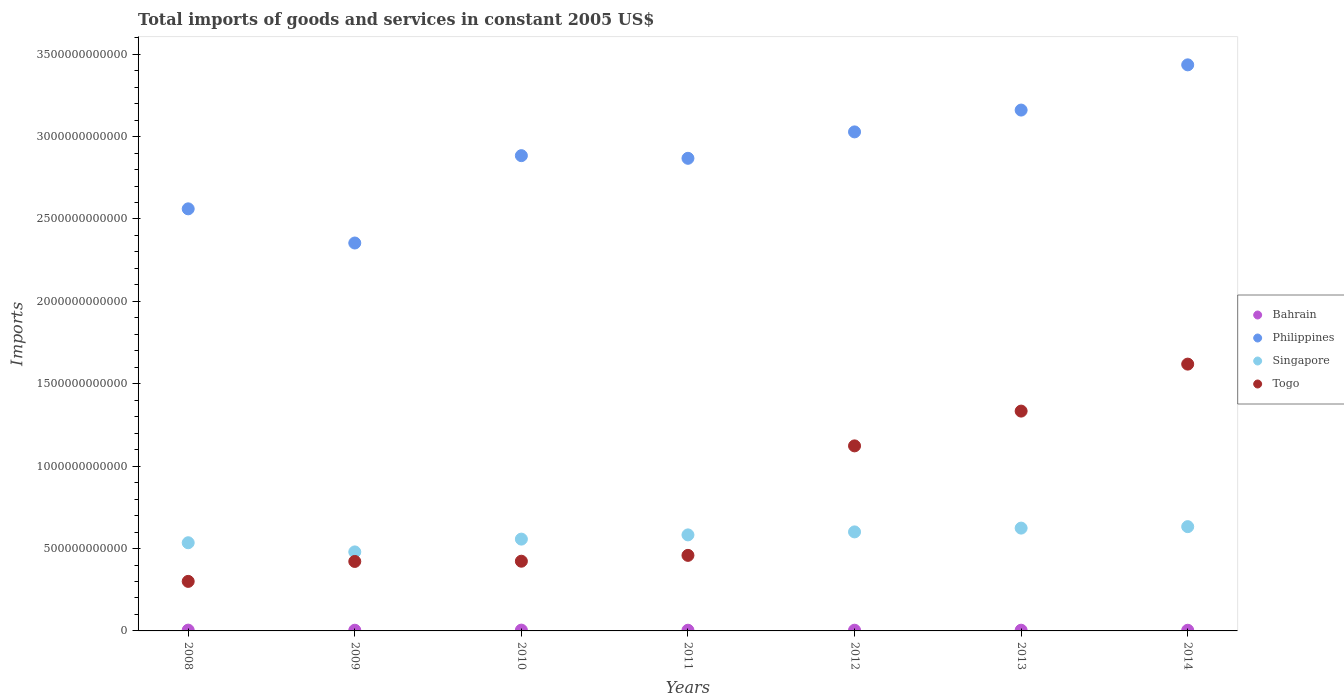Is the number of dotlines equal to the number of legend labels?
Your answer should be very brief. Yes. What is the total imports of goods and services in Philippines in 2011?
Offer a terse response. 2.87e+12. Across all years, what is the maximum total imports of goods and services in Bahrain?
Ensure brevity in your answer.  4.92e+09. Across all years, what is the minimum total imports of goods and services in Bahrain?
Give a very brief answer. 4.06e+09. In which year was the total imports of goods and services in Bahrain minimum?
Your answer should be compact. 2014. What is the total total imports of goods and services in Togo in the graph?
Make the answer very short. 5.68e+12. What is the difference between the total imports of goods and services in Singapore in 2013 and that in 2014?
Provide a succinct answer. -8.82e+09. What is the difference between the total imports of goods and services in Togo in 2014 and the total imports of goods and services in Singapore in 2012?
Offer a terse response. 1.02e+12. What is the average total imports of goods and services in Singapore per year?
Keep it short and to the point. 5.73e+11. In the year 2013, what is the difference between the total imports of goods and services in Philippines and total imports of goods and services in Bahrain?
Give a very brief answer. 3.16e+12. In how many years, is the total imports of goods and services in Singapore greater than 1200000000000 US$?
Provide a short and direct response. 0. What is the ratio of the total imports of goods and services in Philippines in 2009 to that in 2014?
Make the answer very short. 0.69. Is the difference between the total imports of goods and services in Philippines in 2009 and 2011 greater than the difference between the total imports of goods and services in Bahrain in 2009 and 2011?
Your answer should be compact. No. What is the difference between the highest and the second highest total imports of goods and services in Philippines?
Offer a terse response. 2.74e+11. What is the difference between the highest and the lowest total imports of goods and services in Togo?
Keep it short and to the point. 1.32e+12. In how many years, is the total imports of goods and services in Singapore greater than the average total imports of goods and services in Singapore taken over all years?
Your answer should be very brief. 4. Is the total imports of goods and services in Singapore strictly less than the total imports of goods and services in Togo over the years?
Provide a short and direct response. No. How many dotlines are there?
Your answer should be very brief. 4. What is the difference between two consecutive major ticks on the Y-axis?
Your answer should be very brief. 5.00e+11. Does the graph contain any zero values?
Provide a succinct answer. No. Does the graph contain grids?
Provide a succinct answer. No. Where does the legend appear in the graph?
Provide a short and direct response. Center right. How many legend labels are there?
Provide a succinct answer. 4. How are the legend labels stacked?
Make the answer very short. Vertical. What is the title of the graph?
Your answer should be compact. Total imports of goods and services in constant 2005 US$. What is the label or title of the X-axis?
Give a very brief answer. Years. What is the label or title of the Y-axis?
Provide a succinct answer. Imports. What is the Imports in Bahrain in 2008?
Your answer should be very brief. 4.83e+09. What is the Imports in Philippines in 2008?
Offer a very short reply. 2.56e+12. What is the Imports in Singapore in 2008?
Give a very brief answer. 5.35e+11. What is the Imports in Togo in 2008?
Ensure brevity in your answer.  3.01e+11. What is the Imports in Bahrain in 2009?
Your response must be concise. 4.20e+09. What is the Imports in Philippines in 2009?
Provide a succinct answer. 2.35e+12. What is the Imports in Singapore in 2009?
Offer a terse response. 4.80e+11. What is the Imports of Togo in 2009?
Offer a terse response. 4.22e+11. What is the Imports in Bahrain in 2010?
Keep it short and to the point. 4.92e+09. What is the Imports of Philippines in 2010?
Make the answer very short. 2.88e+12. What is the Imports in Singapore in 2010?
Make the answer very short. 5.57e+11. What is the Imports of Togo in 2010?
Your response must be concise. 4.23e+11. What is the Imports of Bahrain in 2011?
Your answer should be very brief. 4.20e+09. What is the Imports in Philippines in 2011?
Ensure brevity in your answer.  2.87e+12. What is the Imports of Singapore in 2011?
Keep it short and to the point. 5.83e+11. What is the Imports in Togo in 2011?
Offer a terse response. 4.59e+11. What is the Imports in Bahrain in 2012?
Provide a short and direct response. 4.30e+09. What is the Imports in Philippines in 2012?
Your response must be concise. 3.03e+12. What is the Imports in Singapore in 2012?
Keep it short and to the point. 6.01e+11. What is the Imports of Togo in 2012?
Provide a short and direct response. 1.12e+12. What is the Imports of Bahrain in 2013?
Offer a very short reply. 4.33e+09. What is the Imports in Philippines in 2013?
Keep it short and to the point. 3.16e+12. What is the Imports of Singapore in 2013?
Keep it short and to the point. 6.24e+11. What is the Imports in Togo in 2013?
Ensure brevity in your answer.  1.33e+12. What is the Imports in Bahrain in 2014?
Give a very brief answer. 4.06e+09. What is the Imports in Philippines in 2014?
Your answer should be compact. 3.44e+12. What is the Imports in Singapore in 2014?
Your answer should be very brief. 6.33e+11. What is the Imports of Togo in 2014?
Provide a short and direct response. 1.62e+12. Across all years, what is the maximum Imports of Bahrain?
Your answer should be compact. 4.92e+09. Across all years, what is the maximum Imports in Philippines?
Make the answer very short. 3.44e+12. Across all years, what is the maximum Imports of Singapore?
Offer a terse response. 6.33e+11. Across all years, what is the maximum Imports of Togo?
Ensure brevity in your answer.  1.62e+12. Across all years, what is the minimum Imports in Bahrain?
Provide a succinct answer. 4.06e+09. Across all years, what is the minimum Imports of Philippines?
Offer a very short reply. 2.35e+12. Across all years, what is the minimum Imports in Singapore?
Your answer should be compact. 4.80e+11. Across all years, what is the minimum Imports in Togo?
Offer a very short reply. 3.01e+11. What is the total Imports of Bahrain in the graph?
Your answer should be very brief. 3.08e+1. What is the total Imports in Philippines in the graph?
Your answer should be compact. 2.03e+13. What is the total Imports in Singapore in the graph?
Offer a terse response. 4.01e+12. What is the total Imports of Togo in the graph?
Ensure brevity in your answer.  5.68e+12. What is the difference between the Imports of Bahrain in 2008 and that in 2009?
Make the answer very short. 6.36e+08. What is the difference between the Imports in Philippines in 2008 and that in 2009?
Give a very brief answer. 2.07e+11. What is the difference between the Imports of Singapore in 2008 and that in 2009?
Provide a succinct answer. 5.56e+1. What is the difference between the Imports of Togo in 2008 and that in 2009?
Ensure brevity in your answer.  -1.21e+11. What is the difference between the Imports of Bahrain in 2008 and that in 2010?
Your answer should be very brief. -9.00e+07. What is the difference between the Imports in Philippines in 2008 and that in 2010?
Offer a terse response. -3.23e+11. What is the difference between the Imports in Singapore in 2008 and that in 2010?
Give a very brief answer. -2.21e+1. What is the difference between the Imports in Togo in 2008 and that in 2010?
Your response must be concise. -1.22e+11. What is the difference between the Imports of Bahrain in 2008 and that in 2011?
Your response must be concise. 6.38e+08. What is the difference between the Imports of Philippines in 2008 and that in 2011?
Your answer should be very brief. -3.07e+11. What is the difference between the Imports in Singapore in 2008 and that in 2011?
Ensure brevity in your answer.  -4.77e+1. What is the difference between the Imports in Togo in 2008 and that in 2011?
Offer a very short reply. -1.58e+11. What is the difference between the Imports in Bahrain in 2008 and that in 2012?
Your response must be concise. 5.40e+08. What is the difference between the Imports in Philippines in 2008 and that in 2012?
Make the answer very short. -4.67e+11. What is the difference between the Imports of Singapore in 2008 and that in 2012?
Provide a succinct answer. -6.58e+1. What is the difference between the Imports in Togo in 2008 and that in 2012?
Provide a succinct answer. -8.22e+11. What is the difference between the Imports in Bahrain in 2008 and that in 2013?
Ensure brevity in your answer.  5.02e+08. What is the difference between the Imports of Philippines in 2008 and that in 2013?
Ensure brevity in your answer.  -5.99e+11. What is the difference between the Imports in Singapore in 2008 and that in 2013?
Provide a short and direct response. -8.88e+1. What is the difference between the Imports of Togo in 2008 and that in 2013?
Provide a short and direct response. -1.03e+12. What is the difference between the Imports in Bahrain in 2008 and that in 2014?
Keep it short and to the point. 7.70e+08. What is the difference between the Imports of Philippines in 2008 and that in 2014?
Make the answer very short. -8.74e+11. What is the difference between the Imports in Singapore in 2008 and that in 2014?
Make the answer very short. -9.77e+1. What is the difference between the Imports in Togo in 2008 and that in 2014?
Provide a short and direct response. -1.32e+12. What is the difference between the Imports of Bahrain in 2009 and that in 2010?
Your answer should be compact. -7.26e+08. What is the difference between the Imports of Philippines in 2009 and that in 2010?
Offer a very short reply. -5.30e+11. What is the difference between the Imports of Singapore in 2009 and that in 2010?
Provide a succinct answer. -7.77e+1. What is the difference between the Imports of Togo in 2009 and that in 2010?
Keep it short and to the point. -1.44e+09. What is the difference between the Imports of Philippines in 2009 and that in 2011?
Offer a terse response. -5.14e+11. What is the difference between the Imports in Singapore in 2009 and that in 2011?
Keep it short and to the point. -1.03e+11. What is the difference between the Imports in Togo in 2009 and that in 2011?
Keep it short and to the point. -3.69e+1. What is the difference between the Imports of Bahrain in 2009 and that in 2012?
Your answer should be compact. -9.70e+07. What is the difference between the Imports of Philippines in 2009 and that in 2012?
Your response must be concise. -6.74e+11. What is the difference between the Imports in Singapore in 2009 and that in 2012?
Offer a very short reply. -1.21e+11. What is the difference between the Imports of Togo in 2009 and that in 2012?
Your answer should be compact. -7.01e+11. What is the difference between the Imports in Bahrain in 2009 and that in 2013?
Offer a very short reply. -1.34e+08. What is the difference between the Imports of Philippines in 2009 and that in 2013?
Your answer should be compact. -8.07e+11. What is the difference between the Imports of Singapore in 2009 and that in 2013?
Make the answer very short. -1.44e+11. What is the difference between the Imports in Togo in 2009 and that in 2013?
Give a very brief answer. -9.12e+11. What is the difference between the Imports of Bahrain in 2009 and that in 2014?
Keep it short and to the point. 1.33e+08. What is the difference between the Imports in Philippines in 2009 and that in 2014?
Provide a short and direct response. -1.08e+12. What is the difference between the Imports of Singapore in 2009 and that in 2014?
Keep it short and to the point. -1.53e+11. What is the difference between the Imports of Togo in 2009 and that in 2014?
Offer a terse response. -1.20e+12. What is the difference between the Imports of Bahrain in 2010 and that in 2011?
Ensure brevity in your answer.  7.28e+08. What is the difference between the Imports of Philippines in 2010 and that in 2011?
Offer a terse response. 1.61e+1. What is the difference between the Imports of Singapore in 2010 and that in 2011?
Offer a very short reply. -2.56e+1. What is the difference between the Imports of Togo in 2010 and that in 2011?
Make the answer very short. -3.55e+1. What is the difference between the Imports of Bahrain in 2010 and that in 2012?
Ensure brevity in your answer.  6.30e+08. What is the difference between the Imports of Philippines in 2010 and that in 2012?
Make the answer very short. -1.44e+11. What is the difference between the Imports in Singapore in 2010 and that in 2012?
Your answer should be very brief. -4.38e+1. What is the difference between the Imports in Togo in 2010 and that in 2012?
Offer a very short reply. -7.00e+11. What is the difference between the Imports in Bahrain in 2010 and that in 2013?
Keep it short and to the point. 5.92e+08. What is the difference between the Imports in Philippines in 2010 and that in 2013?
Your answer should be compact. -2.77e+11. What is the difference between the Imports in Singapore in 2010 and that in 2013?
Your answer should be compact. -6.68e+1. What is the difference between the Imports of Togo in 2010 and that in 2013?
Provide a short and direct response. -9.11e+11. What is the difference between the Imports of Bahrain in 2010 and that in 2014?
Keep it short and to the point. 8.60e+08. What is the difference between the Imports of Philippines in 2010 and that in 2014?
Offer a terse response. -5.51e+11. What is the difference between the Imports in Singapore in 2010 and that in 2014?
Your answer should be very brief. -7.56e+1. What is the difference between the Imports in Togo in 2010 and that in 2014?
Ensure brevity in your answer.  -1.20e+12. What is the difference between the Imports of Bahrain in 2011 and that in 2012?
Your answer should be compact. -9.80e+07. What is the difference between the Imports in Philippines in 2011 and that in 2012?
Your response must be concise. -1.60e+11. What is the difference between the Imports in Singapore in 2011 and that in 2012?
Your answer should be very brief. -1.82e+1. What is the difference between the Imports of Togo in 2011 and that in 2012?
Provide a short and direct response. -6.64e+11. What is the difference between the Imports of Bahrain in 2011 and that in 2013?
Offer a very short reply. -1.35e+08. What is the difference between the Imports in Philippines in 2011 and that in 2013?
Provide a short and direct response. -2.93e+11. What is the difference between the Imports of Singapore in 2011 and that in 2013?
Provide a succinct answer. -4.12e+1. What is the difference between the Imports in Togo in 2011 and that in 2013?
Your response must be concise. -8.76e+11. What is the difference between the Imports in Bahrain in 2011 and that in 2014?
Provide a succinct answer. 1.32e+08. What is the difference between the Imports of Philippines in 2011 and that in 2014?
Ensure brevity in your answer.  -5.67e+11. What is the difference between the Imports of Singapore in 2011 and that in 2014?
Provide a succinct answer. -5.00e+1. What is the difference between the Imports in Togo in 2011 and that in 2014?
Provide a succinct answer. -1.16e+12. What is the difference between the Imports in Bahrain in 2012 and that in 2013?
Make the answer very short. -3.70e+07. What is the difference between the Imports of Philippines in 2012 and that in 2013?
Ensure brevity in your answer.  -1.32e+11. What is the difference between the Imports of Singapore in 2012 and that in 2013?
Ensure brevity in your answer.  -2.30e+1. What is the difference between the Imports of Togo in 2012 and that in 2013?
Ensure brevity in your answer.  -2.11e+11. What is the difference between the Imports of Bahrain in 2012 and that in 2014?
Your answer should be very brief. 2.30e+08. What is the difference between the Imports of Philippines in 2012 and that in 2014?
Provide a short and direct response. -4.07e+11. What is the difference between the Imports of Singapore in 2012 and that in 2014?
Give a very brief answer. -3.18e+1. What is the difference between the Imports in Togo in 2012 and that in 2014?
Offer a terse response. -4.96e+11. What is the difference between the Imports in Bahrain in 2013 and that in 2014?
Give a very brief answer. 2.67e+08. What is the difference between the Imports of Philippines in 2013 and that in 2014?
Your answer should be very brief. -2.74e+11. What is the difference between the Imports in Singapore in 2013 and that in 2014?
Keep it short and to the point. -8.82e+09. What is the difference between the Imports in Togo in 2013 and that in 2014?
Provide a short and direct response. -2.85e+11. What is the difference between the Imports of Bahrain in 2008 and the Imports of Philippines in 2009?
Offer a terse response. -2.35e+12. What is the difference between the Imports in Bahrain in 2008 and the Imports in Singapore in 2009?
Ensure brevity in your answer.  -4.75e+11. What is the difference between the Imports of Bahrain in 2008 and the Imports of Togo in 2009?
Your answer should be very brief. -4.17e+11. What is the difference between the Imports in Philippines in 2008 and the Imports in Singapore in 2009?
Give a very brief answer. 2.08e+12. What is the difference between the Imports of Philippines in 2008 and the Imports of Togo in 2009?
Offer a terse response. 2.14e+12. What is the difference between the Imports of Singapore in 2008 and the Imports of Togo in 2009?
Your answer should be very brief. 1.14e+11. What is the difference between the Imports of Bahrain in 2008 and the Imports of Philippines in 2010?
Your answer should be very brief. -2.88e+12. What is the difference between the Imports in Bahrain in 2008 and the Imports in Singapore in 2010?
Make the answer very short. -5.52e+11. What is the difference between the Imports of Bahrain in 2008 and the Imports of Togo in 2010?
Provide a short and direct response. -4.18e+11. What is the difference between the Imports in Philippines in 2008 and the Imports in Singapore in 2010?
Your response must be concise. 2.00e+12. What is the difference between the Imports of Philippines in 2008 and the Imports of Togo in 2010?
Offer a terse response. 2.14e+12. What is the difference between the Imports in Singapore in 2008 and the Imports in Togo in 2010?
Your answer should be very brief. 1.12e+11. What is the difference between the Imports in Bahrain in 2008 and the Imports in Philippines in 2011?
Provide a short and direct response. -2.86e+12. What is the difference between the Imports of Bahrain in 2008 and the Imports of Singapore in 2011?
Make the answer very short. -5.78e+11. What is the difference between the Imports of Bahrain in 2008 and the Imports of Togo in 2011?
Keep it short and to the point. -4.54e+11. What is the difference between the Imports in Philippines in 2008 and the Imports in Singapore in 2011?
Offer a very short reply. 1.98e+12. What is the difference between the Imports of Philippines in 2008 and the Imports of Togo in 2011?
Ensure brevity in your answer.  2.10e+12. What is the difference between the Imports in Singapore in 2008 and the Imports in Togo in 2011?
Offer a terse response. 7.66e+1. What is the difference between the Imports of Bahrain in 2008 and the Imports of Philippines in 2012?
Provide a succinct answer. -3.02e+12. What is the difference between the Imports of Bahrain in 2008 and the Imports of Singapore in 2012?
Your answer should be very brief. -5.96e+11. What is the difference between the Imports in Bahrain in 2008 and the Imports in Togo in 2012?
Your answer should be compact. -1.12e+12. What is the difference between the Imports of Philippines in 2008 and the Imports of Singapore in 2012?
Your answer should be compact. 1.96e+12. What is the difference between the Imports of Philippines in 2008 and the Imports of Togo in 2012?
Your answer should be very brief. 1.44e+12. What is the difference between the Imports of Singapore in 2008 and the Imports of Togo in 2012?
Keep it short and to the point. -5.88e+11. What is the difference between the Imports of Bahrain in 2008 and the Imports of Philippines in 2013?
Offer a terse response. -3.16e+12. What is the difference between the Imports of Bahrain in 2008 and the Imports of Singapore in 2013?
Your response must be concise. -6.19e+11. What is the difference between the Imports in Bahrain in 2008 and the Imports in Togo in 2013?
Your answer should be very brief. -1.33e+12. What is the difference between the Imports in Philippines in 2008 and the Imports in Singapore in 2013?
Give a very brief answer. 1.94e+12. What is the difference between the Imports in Philippines in 2008 and the Imports in Togo in 2013?
Ensure brevity in your answer.  1.23e+12. What is the difference between the Imports in Singapore in 2008 and the Imports in Togo in 2013?
Keep it short and to the point. -7.99e+11. What is the difference between the Imports of Bahrain in 2008 and the Imports of Philippines in 2014?
Provide a succinct answer. -3.43e+12. What is the difference between the Imports of Bahrain in 2008 and the Imports of Singapore in 2014?
Ensure brevity in your answer.  -6.28e+11. What is the difference between the Imports in Bahrain in 2008 and the Imports in Togo in 2014?
Your answer should be very brief. -1.61e+12. What is the difference between the Imports of Philippines in 2008 and the Imports of Singapore in 2014?
Offer a terse response. 1.93e+12. What is the difference between the Imports in Philippines in 2008 and the Imports in Togo in 2014?
Your response must be concise. 9.42e+11. What is the difference between the Imports of Singapore in 2008 and the Imports of Togo in 2014?
Give a very brief answer. -1.08e+12. What is the difference between the Imports of Bahrain in 2009 and the Imports of Philippines in 2010?
Your response must be concise. -2.88e+12. What is the difference between the Imports of Bahrain in 2009 and the Imports of Singapore in 2010?
Provide a succinct answer. -5.53e+11. What is the difference between the Imports in Bahrain in 2009 and the Imports in Togo in 2010?
Give a very brief answer. -4.19e+11. What is the difference between the Imports of Philippines in 2009 and the Imports of Singapore in 2010?
Offer a very short reply. 1.80e+12. What is the difference between the Imports in Philippines in 2009 and the Imports in Togo in 2010?
Offer a very short reply. 1.93e+12. What is the difference between the Imports of Singapore in 2009 and the Imports of Togo in 2010?
Provide a succinct answer. 5.65e+1. What is the difference between the Imports in Bahrain in 2009 and the Imports in Philippines in 2011?
Provide a succinct answer. -2.86e+12. What is the difference between the Imports of Bahrain in 2009 and the Imports of Singapore in 2011?
Make the answer very short. -5.79e+11. What is the difference between the Imports in Bahrain in 2009 and the Imports in Togo in 2011?
Your response must be concise. -4.54e+11. What is the difference between the Imports in Philippines in 2009 and the Imports in Singapore in 2011?
Provide a succinct answer. 1.77e+12. What is the difference between the Imports of Philippines in 2009 and the Imports of Togo in 2011?
Your response must be concise. 1.90e+12. What is the difference between the Imports of Singapore in 2009 and the Imports of Togo in 2011?
Make the answer very short. 2.10e+1. What is the difference between the Imports of Bahrain in 2009 and the Imports of Philippines in 2012?
Offer a very short reply. -3.02e+12. What is the difference between the Imports of Bahrain in 2009 and the Imports of Singapore in 2012?
Your response must be concise. -5.97e+11. What is the difference between the Imports in Bahrain in 2009 and the Imports in Togo in 2012?
Your response must be concise. -1.12e+12. What is the difference between the Imports of Philippines in 2009 and the Imports of Singapore in 2012?
Offer a terse response. 1.75e+12. What is the difference between the Imports in Philippines in 2009 and the Imports in Togo in 2012?
Provide a succinct answer. 1.23e+12. What is the difference between the Imports of Singapore in 2009 and the Imports of Togo in 2012?
Provide a short and direct response. -6.43e+11. What is the difference between the Imports in Bahrain in 2009 and the Imports in Philippines in 2013?
Provide a short and direct response. -3.16e+12. What is the difference between the Imports in Bahrain in 2009 and the Imports in Singapore in 2013?
Ensure brevity in your answer.  -6.20e+11. What is the difference between the Imports in Bahrain in 2009 and the Imports in Togo in 2013?
Offer a very short reply. -1.33e+12. What is the difference between the Imports of Philippines in 2009 and the Imports of Singapore in 2013?
Your answer should be compact. 1.73e+12. What is the difference between the Imports of Philippines in 2009 and the Imports of Togo in 2013?
Offer a very short reply. 1.02e+12. What is the difference between the Imports in Singapore in 2009 and the Imports in Togo in 2013?
Offer a terse response. -8.54e+11. What is the difference between the Imports in Bahrain in 2009 and the Imports in Philippines in 2014?
Your answer should be compact. -3.43e+12. What is the difference between the Imports in Bahrain in 2009 and the Imports in Singapore in 2014?
Your response must be concise. -6.29e+11. What is the difference between the Imports of Bahrain in 2009 and the Imports of Togo in 2014?
Your response must be concise. -1.61e+12. What is the difference between the Imports in Philippines in 2009 and the Imports in Singapore in 2014?
Offer a terse response. 1.72e+12. What is the difference between the Imports of Philippines in 2009 and the Imports of Togo in 2014?
Your response must be concise. 7.35e+11. What is the difference between the Imports in Singapore in 2009 and the Imports in Togo in 2014?
Offer a terse response. -1.14e+12. What is the difference between the Imports in Bahrain in 2010 and the Imports in Philippines in 2011?
Give a very brief answer. -2.86e+12. What is the difference between the Imports in Bahrain in 2010 and the Imports in Singapore in 2011?
Your answer should be compact. -5.78e+11. What is the difference between the Imports in Bahrain in 2010 and the Imports in Togo in 2011?
Provide a short and direct response. -4.54e+11. What is the difference between the Imports in Philippines in 2010 and the Imports in Singapore in 2011?
Your answer should be very brief. 2.30e+12. What is the difference between the Imports of Philippines in 2010 and the Imports of Togo in 2011?
Offer a very short reply. 2.43e+12. What is the difference between the Imports in Singapore in 2010 and the Imports in Togo in 2011?
Provide a succinct answer. 9.87e+1. What is the difference between the Imports in Bahrain in 2010 and the Imports in Philippines in 2012?
Provide a short and direct response. -3.02e+12. What is the difference between the Imports in Bahrain in 2010 and the Imports in Singapore in 2012?
Provide a succinct answer. -5.96e+11. What is the difference between the Imports of Bahrain in 2010 and the Imports of Togo in 2012?
Your answer should be compact. -1.12e+12. What is the difference between the Imports of Philippines in 2010 and the Imports of Singapore in 2012?
Your answer should be compact. 2.28e+12. What is the difference between the Imports of Philippines in 2010 and the Imports of Togo in 2012?
Give a very brief answer. 1.76e+12. What is the difference between the Imports in Singapore in 2010 and the Imports in Togo in 2012?
Your response must be concise. -5.66e+11. What is the difference between the Imports in Bahrain in 2010 and the Imports in Philippines in 2013?
Your answer should be very brief. -3.16e+12. What is the difference between the Imports of Bahrain in 2010 and the Imports of Singapore in 2013?
Your response must be concise. -6.19e+11. What is the difference between the Imports in Bahrain in 2010 and the Imports in Togo in 2013?
Give a very brief answer. -1.33e+12. What is the difference between the Imports in Philippines in 2010 and the Imports in Singapore in 2013?
Make the answer very short. 2.26e+12. What is the difference between the Imports in Philippines in 2010 and the Imports in Togo in 2013?
Your answer should be compact. 1.55e+12. What is the difference between the Imports in Singapore in 2010 and the Imports in Togo in 2013?
Your answer should be compact. -7.77e+11. What is the difference between the Imports in Bahrain in 2010 and the Imports in Philippines in 2014?
Ensure brevity in your answer.  -3.43e+12. What is the difference between the Imports of Bahrain in 2010 and the Imports of Singapore in 2014?
Ensure brevity in your answer.  -6.28e+11. What is the difference between the Imports of Bahrain in 2010 and the Imports of Togo in 2014?
Provide a short and direct response. -1.61e+12. What is the difference between the Imports of Philippines in 2010 and the Imports of Singapore in 2014?
Ensure brevity in your answer.  2.25e+12. What is the difference between the Imports of Philippines in 2010 and the Imports of Togo in 2014?
Your answer should be compact. 1.27e+12. What is the difference between the Imports in Singapore in 2010 and the Imports in Togo in 2014?
Your response must be concise. -1.06e+12. What is the difference between the Imports of Bahrain in 2011 and the Imports of Philippines in 2012?
Give a very brief answer. -3.02e+12. What is the difference between the Imports in Bahrain in 2011 and the Imports in Singapore in 2012?
Your answer should be very brief. -5.97e+11. What is the difference between the Imports in Bahrain in 2011 and the Imports in Togo in 2012?
Offer a very short reply. -1.12e+12. What is the difference between the Imports of Philippines in 2011 and the Imports of Singapore in 2012?
Keep it short and to the point. 2.27e+12. What is the difference between the Imports of Philippines in 2011 and the Imports of Togo in 2012?
Make the answer very short. 1.75e+12. What is the difference between the Imports of Singapore in 2011 and the Imports of Togo in 2012?
Provide a succinct answer. -5.40e+11. What is the difference between the Imports in Bahrain in 2011 and the Imports in Philippines in 2013?
Ensure brevity in your answer.  -3.16e+12. What is the difference between the Imports of Bahrain in 2011 and the Imports of Singapore in 2013?
Ensure brevity in your answer.  -6.20e+11. What is the difference between the Imports of Bahrain in 2011 and the Imports of Togo in 2013?
Keep it short and to the point. -1.33e+12. What is the difference between the Imports of Philippines in 2011 and the Imports of Singapore in 2013?
Your answer should be compact. 2.24e+12. What is the difference between the Imports of Philippines in 2011 and the Imports of Togo in 2013?
Make the answer very short. 1.53e+12. What is the difference between the Imports of Singapore in 2011 and the Imports of Togo in 2013?
Your answer should be compact. -7.51e+11. What is the difference between the Imports in Bahrain in 2011 and the Imports in Philippines in 2014?
Offer a very short reply. -3.43e+12. What is the difference between the Imports of Bahrain in 2011 and the Imports of Singapore in 2014?
Offer a terse response. -6.29e+11. What is the difference between the Imports in Bahrain in 2011 and the Imports in Togo in 2014?
Offer a very short reply. -1.61e+12. What is the difference between the Imports in Philippines in 2011 and the Imports in Singapore in 2014?
Keep it short and to the point. 2.24e+12. What is the difference between the Imports of Philippines in 2011 and the Imports of Togo in 2014?
Keep it short and to the point. 1.25e+12. What is the difference between the Imports in Singapore in 2011 and the Imports in Togo in 2014?
Ensure brevity in your answer.  -1.04e+12. What is the difference between the Imports in Bahrain in 2012 and the Imports in Philippines in 2013?
Your response must be concise. -3.16e+12. What is the difference between the Imports in Bahrain in 2012 and the Imports in Singapore in 2013?
Offer a terse response. -6.20e+11. What is the difference between the Imports of Bahrain in 2012 and the Imports of Togo in 2013?
Your answer should be very brief. -1.33e+12. What is the difference between the Imports of Philippines in 2012 and the Imports of Singapore in 2013?
Offer a terse response. 2.40e+12. What is the difference between the Imports in Philippines in 2012 and the Imports in Togo in 2013?
Provide a short and direct response. 1.69e+12. What is the difference between the Imports in Singapore in 2012 and the Imports in Togo in 2013?
Offer a very short reply. -7.33e+11. What is the difference between the Imports of Bahrain in 2012 and the Imports of Philippines in 2014?
Ensure brevity in your answer.  -3.43e+12. What is the difference between the Imports of Bahrain in 2012 and the Imports of Singapore in 2014?
Offer a very short reply. -6.28e+11. What is the difference between the Imports of Bahrain in 2012 and the Imports of Togo in 2014?
Provide a short and direct response. -1.61e+12. What is the difference between the Imports in Philippines in 2012 and the Imports in Singapore in 2014?
Ensure brevity in your answer.  2.40e+12. What is the difference between the Imports of Philippines in 2012 and the Imports of Togo in 2014?
Your response must be concise. 1.41e+12. What is the difference between the Imports in Singapore in 2012 and the Imports in Togo in 2014?
Your response must be concise. -1.02e+12. What is the difference between the Imports of Bahrain in 2013 and the Imports of Philippines in 2014?
Ensure brevity in your answer.  -3.43e+12. What is the difference between the Imports in Bahrain in 2013 and the Imports in Singapore in 2014?
Your answer should be compact. -6.28e+11. What is the difference between the Imports of Bahrain in 2013 and the Imports of Togo in 2014?
Offer a very short reply. -1.61e+12. What is the difference between the Imports in Philippines in 2013 and the Imports in Singapore in 2014?
Your response must be concise. 2.53e+12. What is the difference between the Imports in Philippines in 2013 and the Imports in Togo in 2014?
Keep it short and to the point. 1.54e+12. What is the difference between the Imports in Singapore in 2013 and the Imports in Togo in 2014?
Offer a terse response. -9.95e+11. What is the average Imports of Bahrain per year?
Provide a succinct answer. 4.41e+09. What is the average Imports in Philippines per year?
Your answer should be very brief. 2.90e+12. What is the average Imports in Singapore per year?
Give a very brief answer. 5.73e+11. What is the average Imports of Togo per year?
Make the answer very short. 8.11e+11. In the year 2008, what is the difference between the Imports in Bahrain and Imports in Philippines?
Your answer should be very brief. -2.56e+12. In the year 2008, what is the difference between the Imports of Bahrain and Imports of Singapore?
Give a very brief answer. -5.30e+11. In the year 2008, what is the difference between the Imports of Bahrain and Imports of Togo?
Give a very brief answer. -2.96e+11. In the year 2008, what is the difference between the Imports of Philippines and Imports of Singapore?
Your response must be concise. 2.03e+12. In the year 2008, what is the difference between the Imports of Philippines and Imports of Togo?
Offer a terse response. 2.26e+12. In the year 2008, what is the difference between the Imports in Singapore and Imports in Togo?
Offer a very short reply. 2.35e+11. In the year 2009, what is the difference between the Imports in Bahrain and Imports in Philippines?
Make the answer very short. -2.35e+12. In the year 2009, what is the difference between the Imports in Bahrain and Imports in Singapore?
Make the answer very short. -4.75e+11. In the year 2009, what is the difference between the Imports in Bahrain and Imports in Togo?
Offer a terse response. -4.17e+11. In the year 2009, what is the difference between the Imports of Philippines and Imports of Singapore?
Provide a short and direct response. 1.87e+12. In the year 2009, what is the difference between the Imports in Philippines and Imports in Togo?
Provide a succinct answer. 1.93e+12. In the year 2009, what is the difference between the Imports in Singapore and Imports in Togo?
Your response must be concise. 5.79e+1. In the year 2010, what is the difference between the Imports in Bahrain and Imports in Philippines?
Offer a terse response. -2.88e+12. In the year 2010, what is the difference between the Imports in Bahrain and Imports in Singapore?
Your answer should be very brief. -5.52e+11. In the year 2010, what is the difference between the Imports of Bahrain and Imports of Togo?
Offer a very short reply. -4.18e+11. In the year 2010, what is the difference between the Imports of Philippines and Imports of Singapore?
Offer a very short reply. 2.33e+12. In the year 2010, what is the difference between the Imports in Philippines and Imports in Togo?
Provide a succinct answer. 2.46e+12. In the year 2010, what is the difference between the Imports of Singapore and Imports of Togo?
Keep it short and to the point. 1.34e+11. In the year 2011, what is the difference between the Imports of Bahrain and Imports of Philippines?
Your answer should be compact. -2.86e+12. In the year 2011, what is the difference between the Imports in Bahrain and Imports in Singapore?
Offer a very short reply. -5.79e+11. In the year 2011, what is the difference between the Imports in Bahrain and Imports in Togo?
Provide a short and direct response. -4.54e+11. In the year 2011, what is the difference between the Imports in Philippines and Imports in Singapore?
Provide a succinct answer. 2.29e+12. In the year 2011, what is the difference between the Imports of Philippines and Imports of Togo?
Your response must be concise. 2.41e+12. In the year 2011, what is the difference between the Imports of Singapore and Imports of Togo?
Offer a terse response. 1.24e+11. In the year 2012, what is the difference between the Imports in Bahrain and Imports in Philippines?
Offer a terse response. -3.02e+12. In the year 2012, what is the difference between the Imports in Bahrain and Imports in Singapore?
Your response must be concise. -5.97e+11. In the year 2012, what is the difference between the Imports of Bahrain and Imports of Togo?
Offer a very short reply. -1.12e+12. In the year 2012, what is the difference between the Imports of Philippines and Imports of Singapore?
Keep it short and to the point. 2.43e+12. In the year 2012, what is the difference between the Imports in Philippines and Imports in Togo?
Your response must be concise. 1.91e+12. In the year 2012, what is the difference between the Imports of Singapore and Imports of Togo?
Provide a succinct answer. -5.22e+11. In the year 2013, what is the difference between the Imports in Bahrain and Imports in Philippines?
Provide a succinct answer. -3.16e+12. In the year 2013, what is the difference between the Imports in Bahrain and Imports in Singapore?
Your answer should be very brief. -6.20e+11. In the year 2013, what is the difference between the Imports of Bahrain and Imports of Togo?
Ensure brevity in your answer.  -1.33e+12. In the year 2013, what is the difference between the Imports of Philippines and Imports of Singapore?
Your response must be concise. 2.54e+12. In the year 2013, what is the difference between the Imports of Philippines and Imports of Togo?
Give a very brief answer. 1.83e+12. In the year 2013, what is the difference between the Imports of Singapore and Imports of Togo?
Your response must be concise. -7.10e+11. In the year 2014, what is the difference between the Imports in Bahrain and Imports in Philippines?
Give a very brief answer. -3.43e+12. In the year 2014, what is the difference between the Imports of Bahrain and Imports of Singapore?
Your answer should be compact. -6.29e+11. In the year 2014, what is the difference between the Imports of Bahrain and Imports of Togo?
Make the answer very short. -1.62e+12. In the year 2014, what is the difference between the Imports in Philippines and Imports in Singapore?
Offer a very short reply. 2.80e+12. In the year 2014, what is the difference between the Imports of Philippines and Imports of Togo?
Your response must be concise. 1.82e+12. In the year 2014, what is the difference between the Imports in Singapore and Imports in Togo?
Your answer should be compact. -9.86e+11. What is the ratio of the Imports in Bahrain in 2008 to that in 2009?
Make the answer very short. 1.15. What is the ratio of the Imports in Philippines in 2008 to that in 2009?
Offer a very short reply. 1.09. What is the ratio of the Imports of Singapore in 2008 to that in 2009?
Offer a terse response. 1.12. What is the ratio of the Imports of Togo in 2008 to that in 2009?
Offer a very short reply. 0.71. What is the ratio of the Imports of Bahrain in 2008 to that in 2010?
Offer a very short reply. 0.98. What is the ratio of the Imports in Philippines in 2008 to that in 2010?
Your response must be concise. 0.89. What is the ratio of the Imports of Singapore in 2008 to that in 2010?
Keep it short and to the point. 0.96. What is the ratio of the Imports of Togo in 2008 to that in 2010?
Offer a very short reply. 0.71. What is the ratio of the Imports of Bahrain in 2008 to that in 2011?
Keep it short and to the point. 1.15. What is the ratio of the Imports in Philippines in 2008 to that in 2011?
Your answer should be compact. 0.89. What is the ratio of the Imports in Singapore in 2008 to that in 2011?
Offer a very short reply. 0.92. What is the ratio of the Imports of Togo in 2008 to that in 2011?
Make the answer very short. 0.66. What is the ratio of the Imports in Bahrain in 2008 to that in 2012?
Your answer should be very brief. 1.13. What is the ratio of the Imports of Philippines in 2008 to that in 2012?
Keep it short and to the point. 0.85. What is the ratio of the Imports in Singapore in 2008 to that in 2012?
Give a very brief answer. 0.89. What is the ratio of the Imports in Togo in 2008 to that in 2012?
Your answer should be very brief. 0.27. What is the ratio of the Imports of Bahrain in 2008 to that in 2013?
Give a very brief answer. 1.12. What is the ratio of the Imports in Philippines in 2008 to that in 2013?
Your answer should be compact. 0.81. What is the ratio of the Imports in Singapore in 2008 to that in 2013?
Offer a terse response. 0.86. What is the ratio of the Imports of Togo in 2008 to that in 2013?
Your answer should be compact. 0.23. What is the ratio of the Imports in Bahrain in 2008 to that in 2014?
Your answer should be very brief. 1.19. What is the ratio of the Imports of Philippines in 2008 to that in 2014?
Offer a very short reply. 0.75. What is the ratio of the Imports in Singapore in 2008 to that in 2014?
Your response must be concise. 0.85. What is the ratio of the Imports in Togo in 2008 to that in 2014?
Keep it short and to the point. 0.19. What is the ratio of the Imports in Bahrain in 2009 to that in 2010?
Make the answer very short. 0.85. What is the ratio of the Imports of Philippines in 2009 to that in 2010?
Provide a succinct answer. 0.82. What is the ratio of the Imports of Singapore in 2009 to that in 2010?
Your answer should be compact. 0.86. What is the ratio of the Imports of Togo in 2009 to that in 2010?
Provide a short and direct response. 1. What is the ratio of the Imports in Philippines in 2009 to that in 2011?
Your answer should be very brief. 0.82. What is the ratio of the Imports of Singapore in 2009 to that in 2011?
Make the answer very short. 0.82. What is the ratio of the Imports of Togo in 2009 to that in 2011?
Make the answer very short. 0.92. What is the ratio of the Imports in Bahrain in 2009 to that in 2012?
Make the answer very short. 0.98. What is the ratio of the Imports in Philippines in 2009 to that in 2012?
Offer a very short reply. 0.78. What is the ratio of the Imports in Singapore in 2009 to that in 2012?
Offer a terse response. 0.8. What is the ratio of the Imports in Togo in 2009 to that in 2012?
Your answer should be compact. 0.38. What is the ratio of the Imports of Bahrain in 2009 to that in 2013?
Ensure brevity in your answer.  0.97. What is the ratio of the Imports in Philippines in 2009 to that in 2013?
Offer a very short reply. 0.74. What is the ratio of the Imports in Singapore in 2009 to that in 2013?
Your answer should be very brief. 0.77. What is the ratio of the Imports of Togo in 2009 to that in 2013?
Provide a succinct answer. 0.32. What is the ratio of the Imports of Bahrain in 2009 to that in 2014?
Give a very brief answer. 1.03. What is the ratio of the Imports of Philippines in 2009 to that in 2014?
Your answer should be very brief. 0.69. What is the ratio of the Imports of Singapore in 2009 to that in 2014?
Make the answer very short. 0.76. What is the ratio of the Imports of Togo in 2009 to that in 2014?
Offer a very short reply. 0.26. What is the ratio of the Imports of Bahrain in 2010 to that in 2011?
Your answer should be very brief. 1.17. What is the ratio of the Imports of Philippines in 2010 to that in 2011?
Offer a terse response. 1.01. What is the ratio of the Imports of Singapore in 2010 to that in 2011?
Keep it short and to the point. 0.96. What is the ratio of the Imports of Togo in 2010 to that in 2011?
Your answer should be compact. 0.92. What is the ratio of the Imports of Bahrain in 2010 to that in 2012?
Offer a very short reply. 1.15. What is the ratio of the Imports of Philippines in 2010 to that in 2012?
Your answer should be compact. 0.95. What is the ratio of the Imports of Singapore in 2010 to that in 2012?
Offer a very short reply. 0.93. What is the ratio of the Imports in Togo in 2010 to that in 2012?
Your answer should be very brief. 0.38. What is the ratio of the Imports in Bahrain in 2010 to that in 2013?
Provide a succinct answer. 1.14. What is the ratio of the Imports in Philippines in 2010 to that in 2013?
Your answer should be compact. 0.91. What is the ratio of the Imports of Singapore in 2010 to that in 2013?
Your answer should be compact. 0.89. What is the ratio of the Imports in Togo in 2010 to that in 2013?
Your answer should be compact. 0.32. What is the ratio of the Imports of Bahrain in 2010 to that in 2014?
Offer a terse response. 1.21. What is the ratio of the Imports in Philippines in 2010 to that in 2014?
Make the answer very short. 0.84. What is the ratio of the Imports in Singapore in 2010 to that in 2014?
Keep it short and to the point. 0.88. What is the ratio of the Imports in Togo in 2010 to that in 2014?
Your answer should be compact. 0.26. What is the ratio of the Imports in Bahrain in 2011 to that in 2012?
Your answer should be compact. 0.98. What is the ratio of the Imports in Philippines in 2011 to that in 2012?
Your answer should be compact. 0.95. What is the ratio of the Imports in Singapore in 2011 to that in 2012?
Keep it short and to the point. 0.97. What is the ratio of the Imports in Togo in 2011 to that in 2012?
Provide a succinct answer. 0.41. What is the ratio of the Imports in Bahrain in 2011 to that in 2013?
Your answer should be very brief. 0.97. What is the ratio of the Imports of Philippines in 2011 to that in 2013?
Your answer should be very brief. 0.91. What is the ratio of the Imports of Singapore in 2011 to that in 2013?
Provide a succinct answer. 0.93. What is the ratio of the Imports in Togo in 2011 to that in 2013?
Your response must be concise. 0.34. What is the ratio of the Imports in Bahrain in 2011 to that in 2014?
Offer a terse response. 1.03. What is the ratio of the Imports in Philippines in 2011 to that in 2014?
Ensure brevity in your answer.  0.83. What is the ratio of the Imports in Singapore in 2011 to that in 2014?
Offer a very short reply. 0.92. What is the ratio of the Imports in Togo in 2011 to that in 2014?
Offer a terse response. 0.28. What is the ratio of the Imports of Bahrain in 2012 to that in 2013?
Your answer should be very brief. 0.99. What is the ratio of the Imports of Philippines in 2012 to that in 2013?
Offer a terse response. 0.96. What is the ratio of the Imports in Singapore in 2012 to that in 2013?
Offer a very short reply. 0.96. What is the ratio of the Imports of Togo in 2012 to that in 2013?
Make the answer very short. 0.84. What is the ratio of the Imports of Bahrain in 2012 to that in 2014?
Your answer should be compact. 1.06. What is the ratio of the Imports in Philippines in 2012 to that in 2014?
Ensure brevity in your answer.  0.88. What is the ratio of the Imports in Singapore in 2012 to that in 2014?
Provide a succinct answer. 0.95. What is the ratio of the Imports in Togo in 2012 to that in 2014?
Give a very brief answer. 0.69. What is the ratio of the Imports in Bahrain in 2013 to that in 2014?
Give a very brief answer. 1.07. What is the ratio of the Imports in Philippines in 2013 to that in 2014?
Keep it short and to the point. 0.92. What is the ratio of the Imports of Singapore in 2013 to that in 2014?
Keep it short and to the point. 0.99. What is the ratio of the Imports in Togo in 2013 to that in 2014?
Your answer should be very brief. 0.82. What is the difference between the highest and the second highest Imports of Bahrain?
Your answer should be compact. 9.00e+07. What is the difference between the highest and the second highest Imports in Philippines?
Your answer should be very brief. 2.74e+11. What is the difference between the highest and the second highest Imports in Singapore?
Offer a terse response. 8.82e+09. What is the difference between the highest and the second highest Imports in Togo?
Offer a very short reply. 2.85e+11. What is the difference between the highest and the lowest Imports of Bahrain?
Give a very brief answer. 8.60e+08. What is the difference between the highest and the lowest Imports in Philippines?
Give a very brief answer. 1.08e+12. What is the difference between the highest and the lowest Imports in Singapore?
Ensure brevity in your answer.  1.53e+11. What is the difference between the highest and the lowest Imports of Togo?
Give a very brief answer. 1.32e+12. 